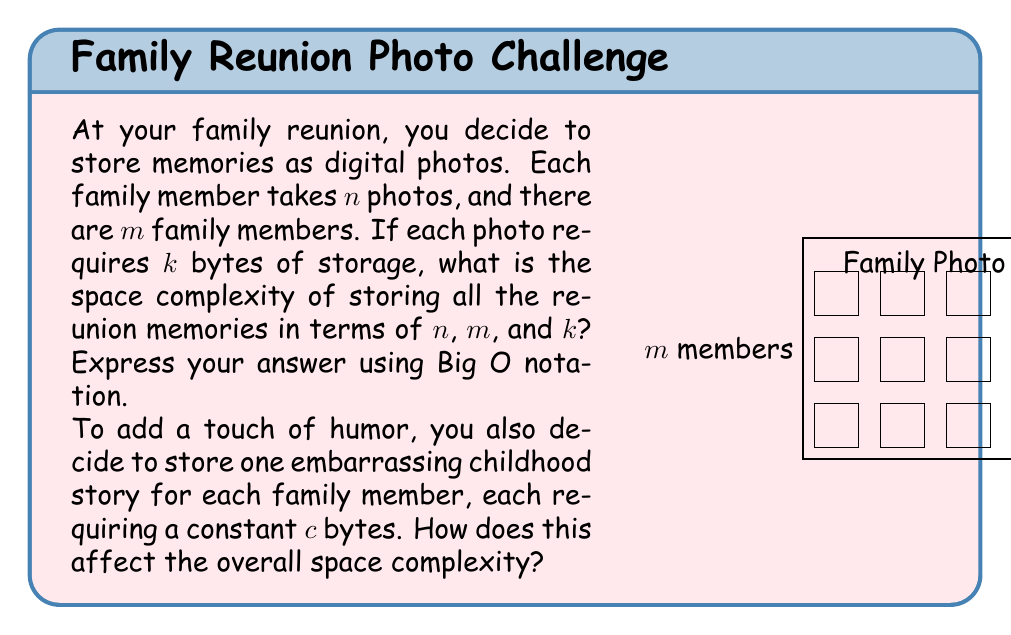Provide a solution to this math problem. Let's approach this step-by-step:

1) First, let's calculate the total number of photos:
   - Each family member takes $n$ photos
   - There are $m$ family members
   - Total number of photos = $n \times m$

2) Each photo requires $k$ bytes of storage. So, the total storage for photos is:
   $$ \text{Total photo storage} = n \times m \times k \text{ bytes} $$

3) The space complexity for storing photos is therefore $O(nmk)$.

4) Now, let's consider the embarrassing childhood stories:
   - There is one story per family member
   - Each story requires a constant $c$ bytes
   - Total storage for stories = $m \times c \text{ bytes}$

5) The space complexity for storing stories is $O(m)$, since $c$ is a constant.

6) To get the overall space complexity, we add these together:
   $$ O(nmk) + O(m) $$

7) In Big O notation, we keep the term with the highest growth rate. Since $O(nmk)$ grows faster than $O(m)$ (assuming $n$ and $k$ are not constant), the overall space complexity remains $O(nmk)$.

Therefore, adding the embarrassing stories doesn't change the overall space complexity.
Answer: $O(nmk)$ 